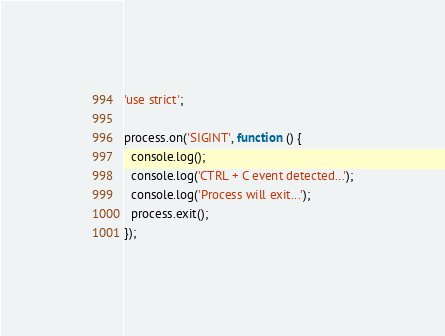Convert code to text. <code><loc_0><loc_0><loc_500><loc_500><_JavaScript_>'use strict';

process.on('SIGINT', function () {
  console.log();
  console.log('CTRL + C event detected...');
  console.log('Process will exit...');
  process.exit();
});</code> 